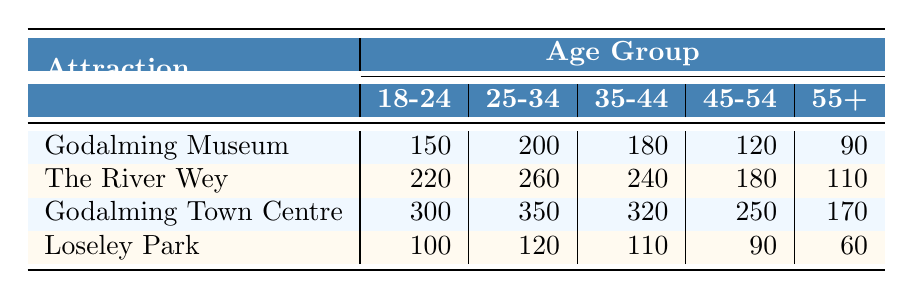What is the visitor count for the Godalming Museum from the age group 25-34? Referring to the table, the visitor count for Godalming Museum in the age group 25-34 is directly shown as 200.
Answer: 200 Which attraction had the highest visitor count for the age group 18-24? By checking the 18-24 row for each attraction, Godalming Town Centre has the highest count with 300 visitors compared to Godalming Museum (150), The River Wey (220), and Loseley Park (100).
Answer: 300 What is the total number of visitors aged 45-54 across all attractions? Summing up the visitor counts aged 45-54: Godalming Museum (120) + The River Wey (180) + Godalming Town Centre (250) + Loseley Park (90) gives us a total of 640 visitors.
Answer: 640 Is the number of visitors aged 55+ at Loseley Park greater than 50? The table shows that Loseley Park has 60 visitors for the aged 55+ category, which is indeed greater than 50.
Answer: Yes How many more visitors aged 25-34 visited The River Wey compared to Godalming Museum? The visitor count for The River Wey in the age group 25-34 is 260, while for Godalming Museum it is 200. The difference is 260 - 200 = 60 visitors more at The River Wey.
Answer: 60 What is the average visitor count for the 35-44 age group across all attractions? The visitor counts for the 35-44 age group are: Godalming Museum (180), The River Wey (240), Godalming Town Centre (320), and Loseley Park (110). Summing these gives 850, and dividing by 4 attractions gives an average of 212.5.
Answer: 212.5 Does the total number of visitors aged 18-24 at Godalming Museum exceed that at Loseley Park? The visitor counts are 150 for Godalming Museum and 100 for Loseley Park, so 150 exceeds 100.
Answer: Yes Which age group had the least visitors at Loseley Park? Checking the visitor counts for Loseley Park, the group 55+ with 60 visitors is the lowest compared to other age groups: 100, 120, 110, and 90.
Answer: 55+ 